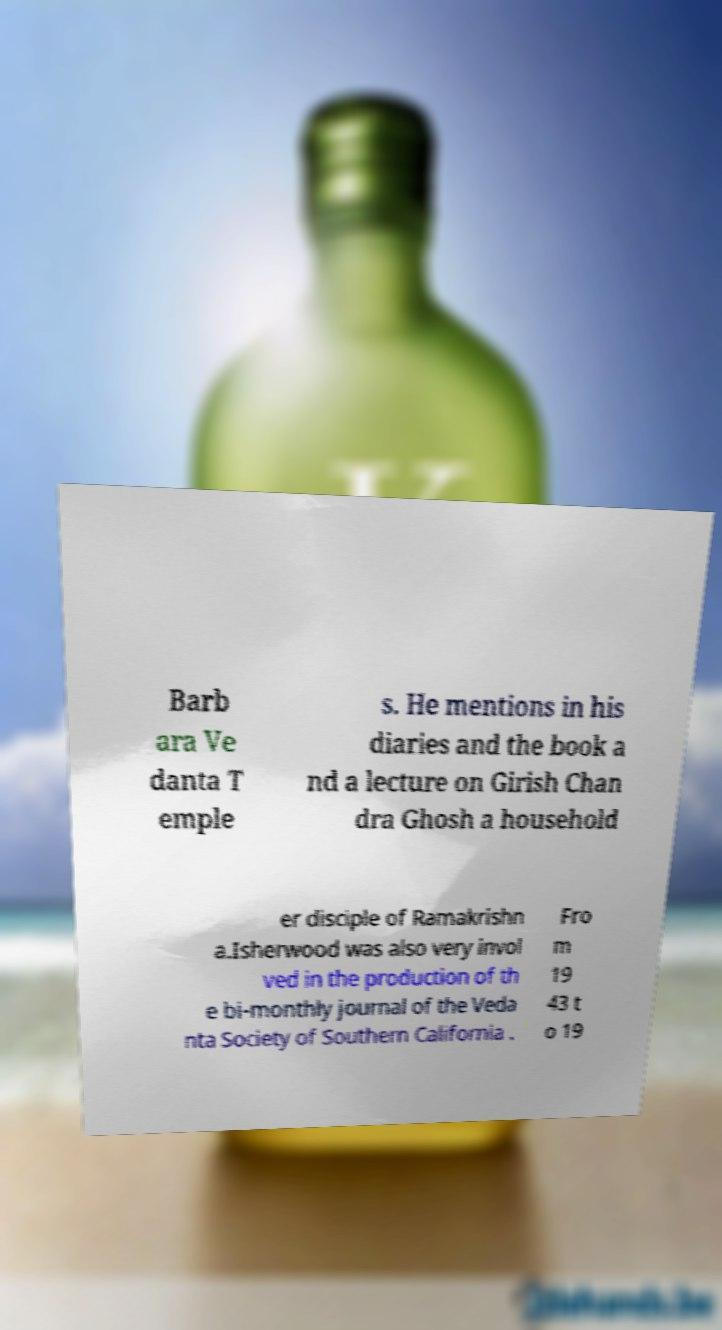Could you extract and type out the text from this image? Barb ara Ve danta T emple s. He mentions in his diaries and the book a nd a lecture on Girish Chan dra Ghosh a household er disciple of Ramakrishn a.Isherwood was also very invol ved in the production of th e bi-monthly journal of the Veda nta Society of Southern California . Fro m 19 43 t o 19 